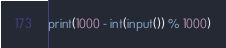<code> <loc_0><loc_0><loc_500><loc_500><_Python_>print(1000 - int(input()) % 1000)</code> 